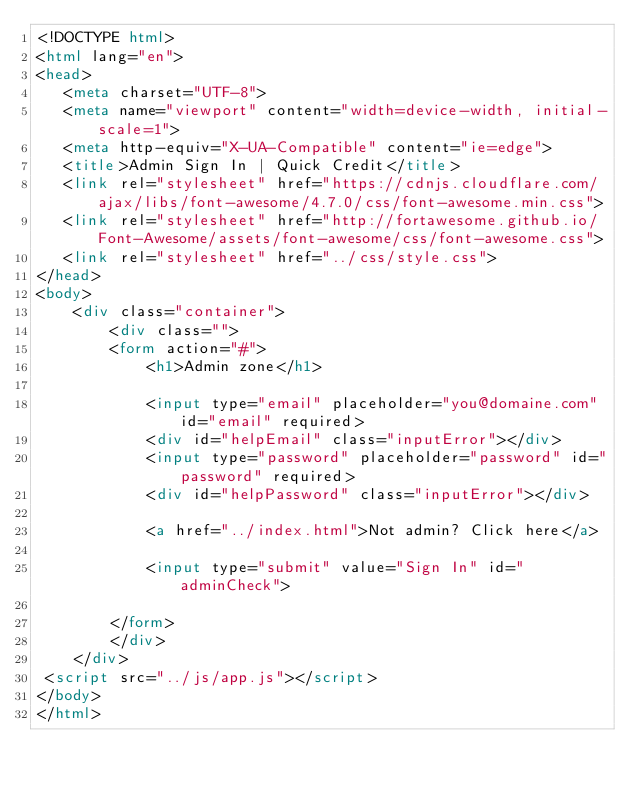Convert code to text. <code><loc_0><loc_0><loc_500><loc_500><_HTML_><!DOCTYPE html>
<html lang="en">
<head>
   <meta charset="UTF-8">
   <meta name="viewport" content="width=device-width, initial-scale=1">
   <meta http-equiv="X-UA-Compatible" content="ie=edge">
   <title>Admin Sign In | Quick Credit</title>
   <link rel="stylesheet" href="https://cdnjs.cloudflare.com/ajax/libs/font-awesome/4.7.0/css/font-awesome.min.css">
   <link rel="stylesheet" href="http://fortawesome.github.io/Font-Awesome/assets/font-awesome/css/font-awesome.css">   
   <link rel="stylesheet" href="../css/style.css">
</head>
<body>
    <div class="container">
        <div class="">
        <form action="#">
            <h1>Admin zone</h1>
            
            <input type="email" placeholder="you@domaine.com" id="email" required>
            <div id="helpEmail" class="inputError"></div>
            <input type="password" placeholder="password" id="password" required>
            <div id="helpPassword" class="inputError"></div>

            <a href="../index.html">Not admin? Click here</a>
            
            <input type="submit" value="Sign In" id="adminCheck">
                    
        </form>
        </div>
    </div>
 <script src="../js/app.js"></script>
</body>
</html></code> 